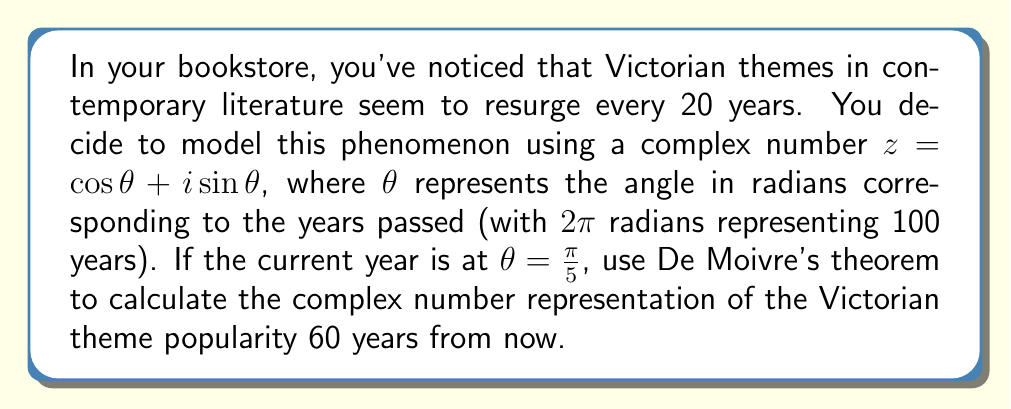Could you help me with this problem? To solve this problem, we'll use De Moivre's theorem and follow these steps:

1) De Moivre's theorem states that for any real number $x$ and integer $n$:

   $(\cos x + i \sin x)^n = \cos(nx) + i \sin(nx)$

2) In our case, $z = \cos\theta + i\sin\theta$ where $\theta = \frac{\pi}{5}$

3) We want to find the state after 60 years. Since 100 years correspond to $2\pi$ radians, 60 years correspond to $\frac{6\pi}{5}$ radians.

4) To get from $\frac{\pi}{5}$ to $\frac{6\pi}{5}$, we need to rotate by $\pi$ radians, which is equivalent to raising $z$ to the power of 3:

   $z^3 = (\cos\frac{\pi}{5} + i\sin\frac{\pi}{5})^3$

5) Applying De Moivre's theorem:

   $z^3 = \cos(\frac{3\pi}{5}) + i\sin(\frac{3\pi}{5})$

6) We can calculate these values:

   $\cos(\frac{3\pi}{5}) = \frac{1-\sqrt{5}}{4}$
   
   $\sin(\frac{3\pi}{5}) = \frac{\sqrt{10+2\sqrt{5}}}{4}$

Therefore, the complex number representation of the Victorian theme popularity 60 years from now is:

$$z^3 = \frac{1-\sqrt{5}}{4} + i\frac{\sqrt{10+2\sqrt{5}}}{4}$$
Answer: $$\frac{1-\sqrt{5}}{4} + i\frac{\sqrt{10+2\sqrt{5}}}{4}$$ 